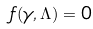<formula> <loc_0><loc_0><loc_500><loc_500>f ( \gamma , \Lambda ) = 0</formula> 